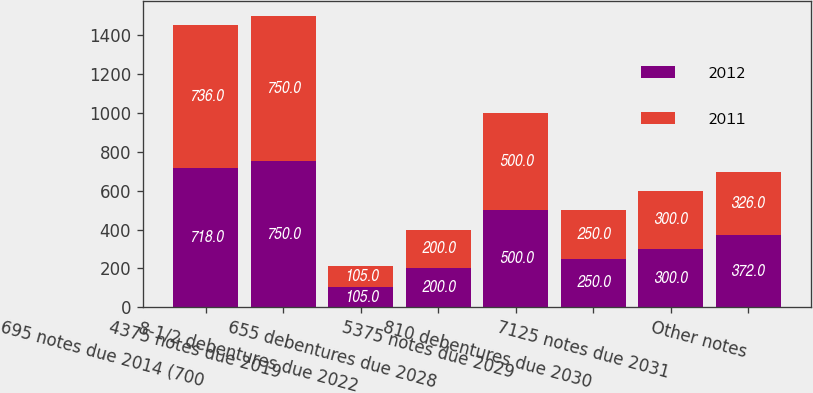Convert chart to OTSL. <chart><loc_0><loc_0><loc_500><loc_500><stacked_bar_chart><ecel><fcel>695 notes due 2014 (700<fcel>4375 notes due 2019<fcel>8-1/2 debentures due 2022<fcel>655 debentures due 2028<fcel>5375 notes due 2029<fcel>810 debentures due 2030<fcel>7125 notes due 2031<fcel>Other notes<nl><fcel>2012<fcel>718<fcel>750<fcel>105<fcel>200<fcel>500<fcel>250<fcel>300<fcel>372<nl><fcel>2011<fcel>736<fcel>750<fcel>105<fcel>200<fcel>500<fcel>250<fcel>300<fcel>326<nl></chart> 